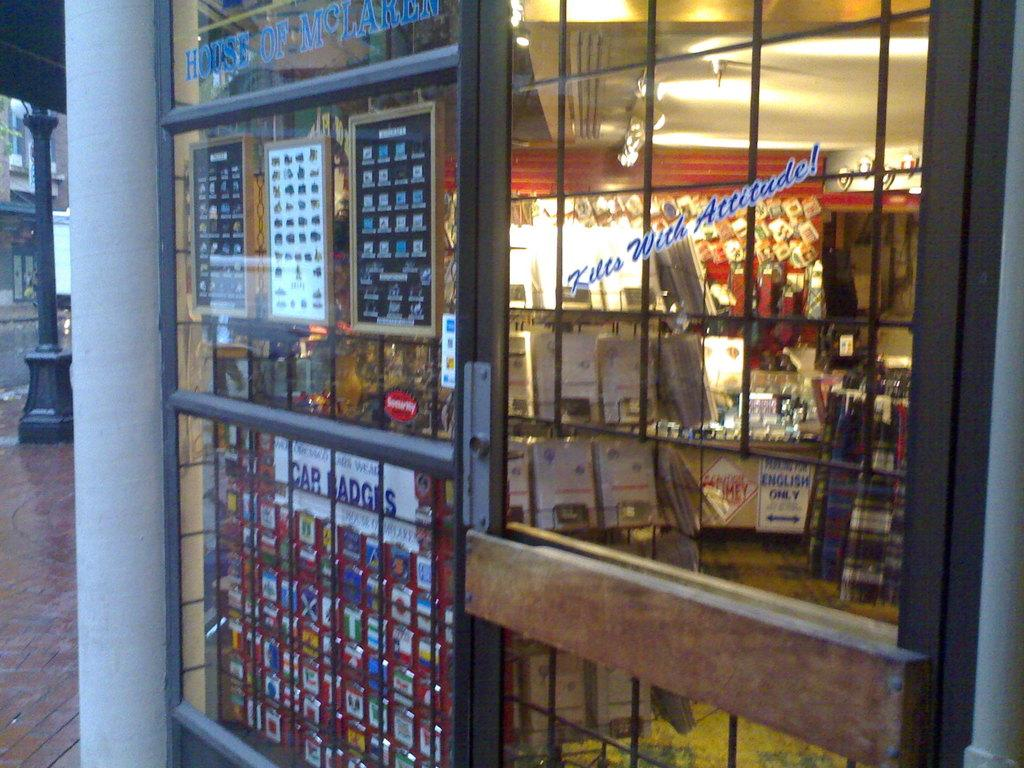<image>
Write a terse but informative summary of the picture. a closed shop with bars and window sign reading Kilts With Attitude 